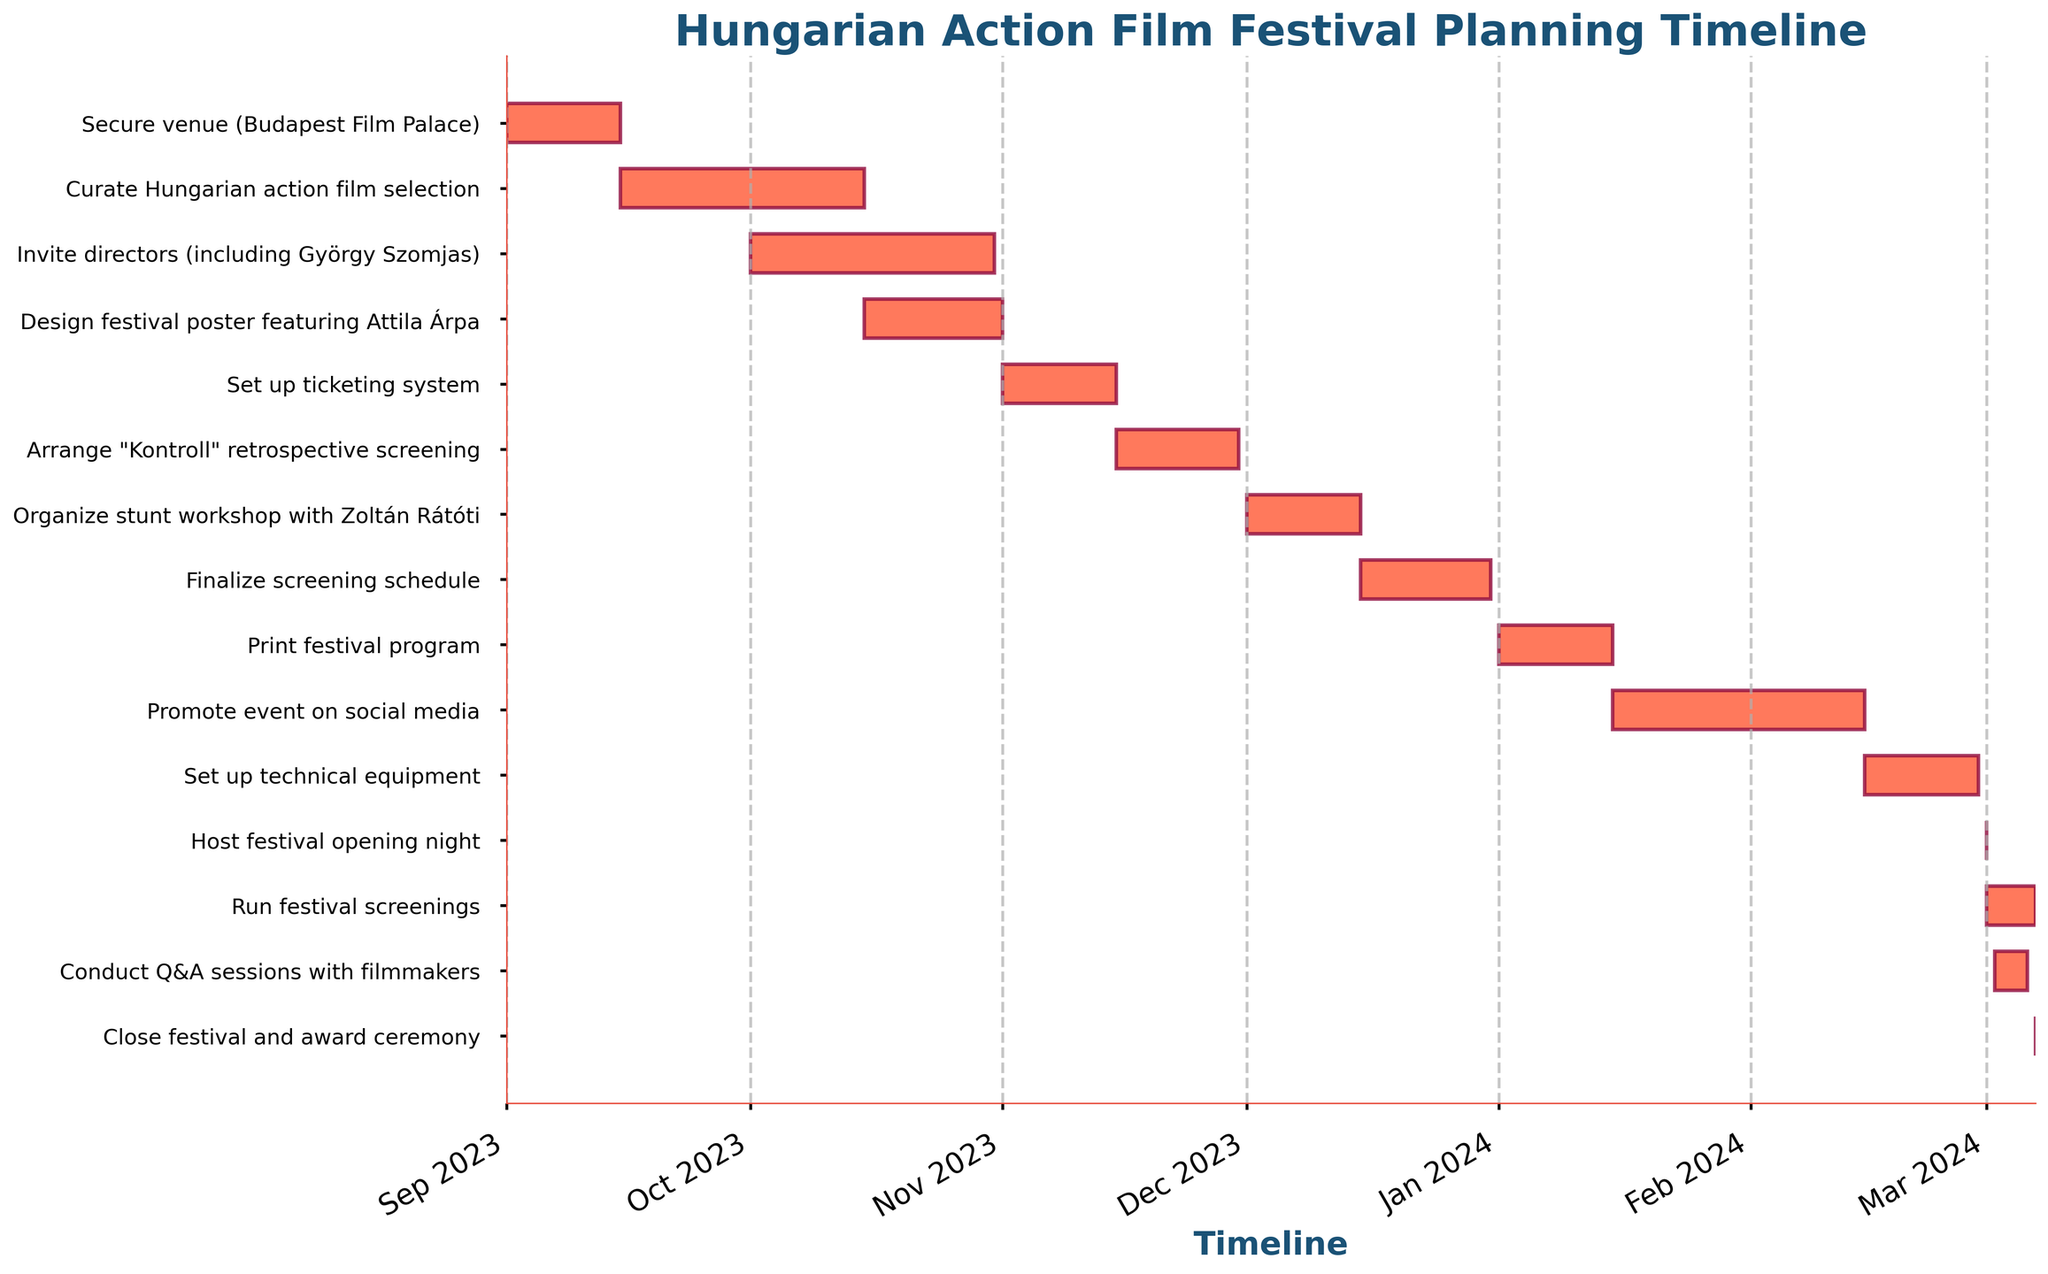What's the title of the Gantt Chart? The title is displayed at the top of the Gantt Chart and describes what the plot is about. It's usually large and prominently positioned.
Answer: Hungarian Action Film Festival Planning Timeline When does the task of curating the Hungarian action film selection start? By looking at the left end of the bar corresponding to the task "Curate Hungarian action film selection," you can find its start date.
Answer: 2023-09-15 Which task has the longest duration? You need to evaluate all the bars and their corresponding durations. The longest bar represents the task with the longest duration.
Answer: Promote event on social media How long is the stunt workshop with Zoltán Rátóti scheduled to last? Identify the bar for "Organize stunt workshop with Zoltán Rátóti" and count the number of days between its start and end dates.
Answer: 15 days What tasks are scheduled to start in December 2023? Look for bars with starting points within December 2023. Note their respective tasks.
Answer: Organize stunt workshop with Zoltán Rátóti, Finalize screening schedule Which task is set to occur right before the festival opening night? Find the bar for "Host festival opening night" and check the task that ends just before its start date.
Answer: Set up technical equipment What is the duration of the task to set up the technical equipment? Find the bar for "Set up technical equipment," then calculate the duration by subtracting the start date from the end date.
Answer: 14 days How many tasks are there in total for this festival planning? Count the number of bars plotted on the chart, as each represents a unique task.
Answer: 14 tasks Between which months does the majority of the planning activities occur? Observe the distribution of the bars in terms of months and note where most of the activity bars are concentrated.
Answer: From September 2023 to March 2024 Does the task of printing the festival program overlap with the task of promoting the event on social media? Check if the bar for "Print festival program" has any overlapping dates with the bar for "Promote event on social media."
Answer: Yes 